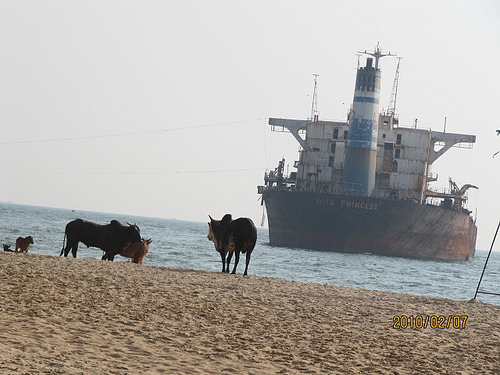Identify the text contained in this image. 2010 02 07 